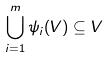<formula> <loc_0><loc_0><loc_500><loc_500>\bigcup _ { i = 1 } ^ { m } \psi _ { i } ( V ) \subseteq V</formula> 